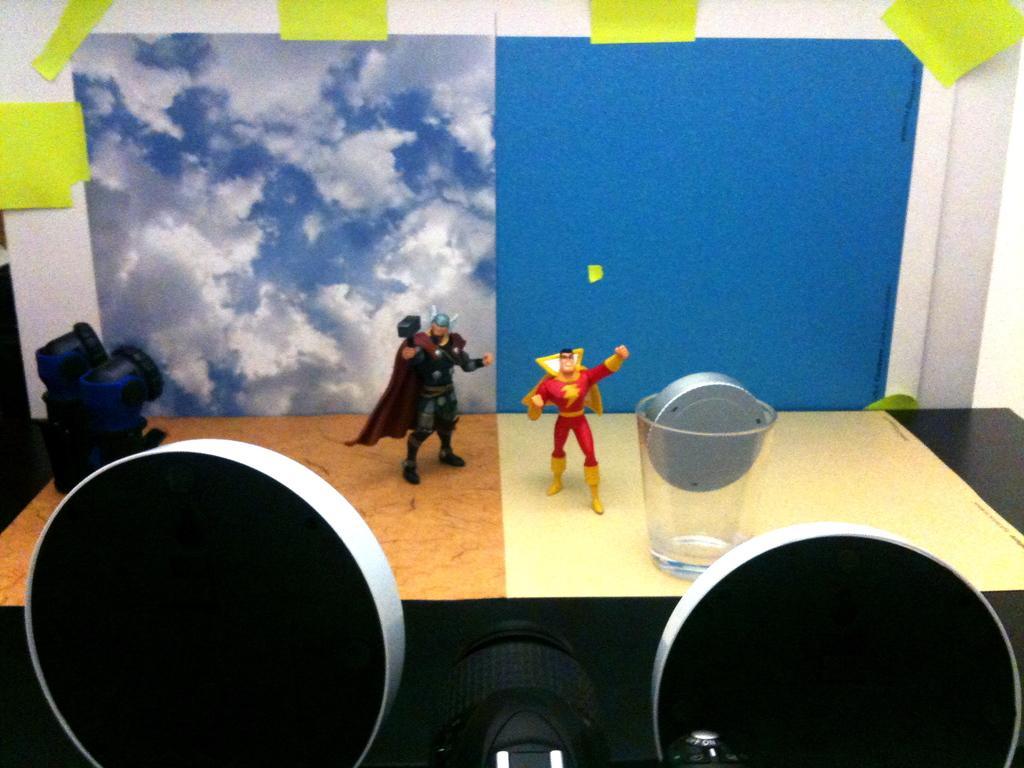Could you give a brief overview of what you see in this image? In this image we can see the depiction of persons on the paper. We can also see the glass and some other objects on the black color table. In the background we can see the paper with the sky and clouds. We can also see a blue color paper attached to the white color background. 